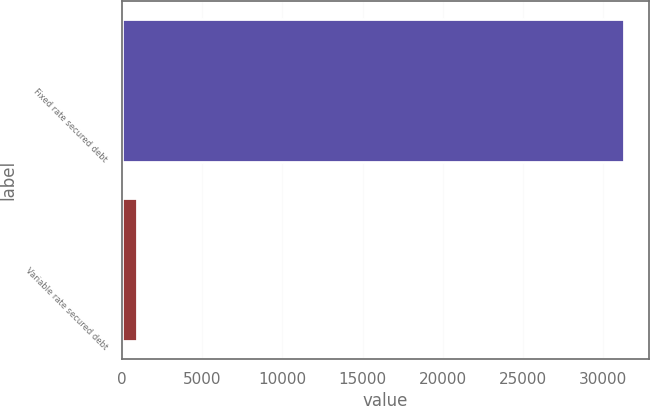Convert chart to OTSL. <chart><loc_0><loc_0><loc_500><loc_500><bar_chart><fcel>Fixed rate secured debt<fcel>Variable rate secured debt<nl><fcel>31290<fcel>935<nl></chart> 